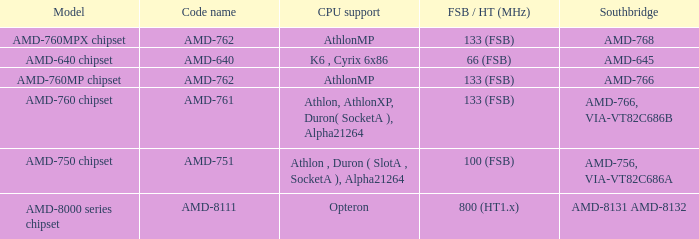What is the code name when the Southbridge shows as amd-766, via-vt82c686b? AMD-761. 